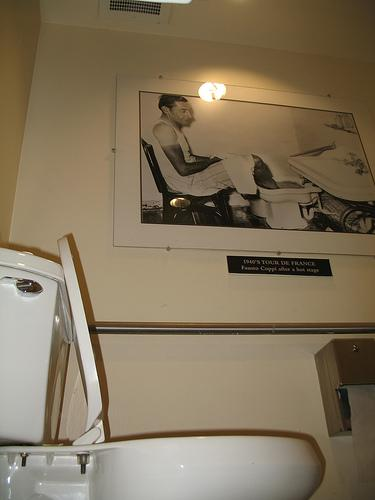Describe the most interesting feature of the image. There's a picture on the wall of a man soaking his feet while sitting in a black chair. Explain what the photograph on the wall depicts. The photograph shows an athlete sitting in a black chair, soaking his feet. Mention the most important object in the image along with its main characteristic. A white toilet with the seat up is the central object in the picture. Share your impression of the bathroom's design. The bathroom design combines vintage elements with modern fixtures, such as a clean, white porcelain toilet and interesting wall art. Describe the role of lighting in the image composition. There is a reflection of light on glass in the picture, drawing attention to the vintage poster and adding depth to the scene. Identify the primary components of the image and their color. The main components are a white toilet with the seat up, a black sign under a wall picture, and a silver handle on the toilet tank. Briefly describe the overall atmosphere of the image. The image exudes a vintage and somewhat quirky atmosphere, with the photograph on the wall and the black sign with gold letters. Narrate the details of the toilet's appearance. The toilet is white and porcelain with the seat up, revealing a clean bowl, and featuring a silver handle on the tank. Comment on the wall decoration in the image. The wall decoration includes a vintage poster and a black sign with gold letters below the photo of a man soaking his feet. Summarize the scene depicted in the image in one sentence. The image shows a restroom with a white toilet with the seat up and a photograph of a man soaking his feet on the wall. 